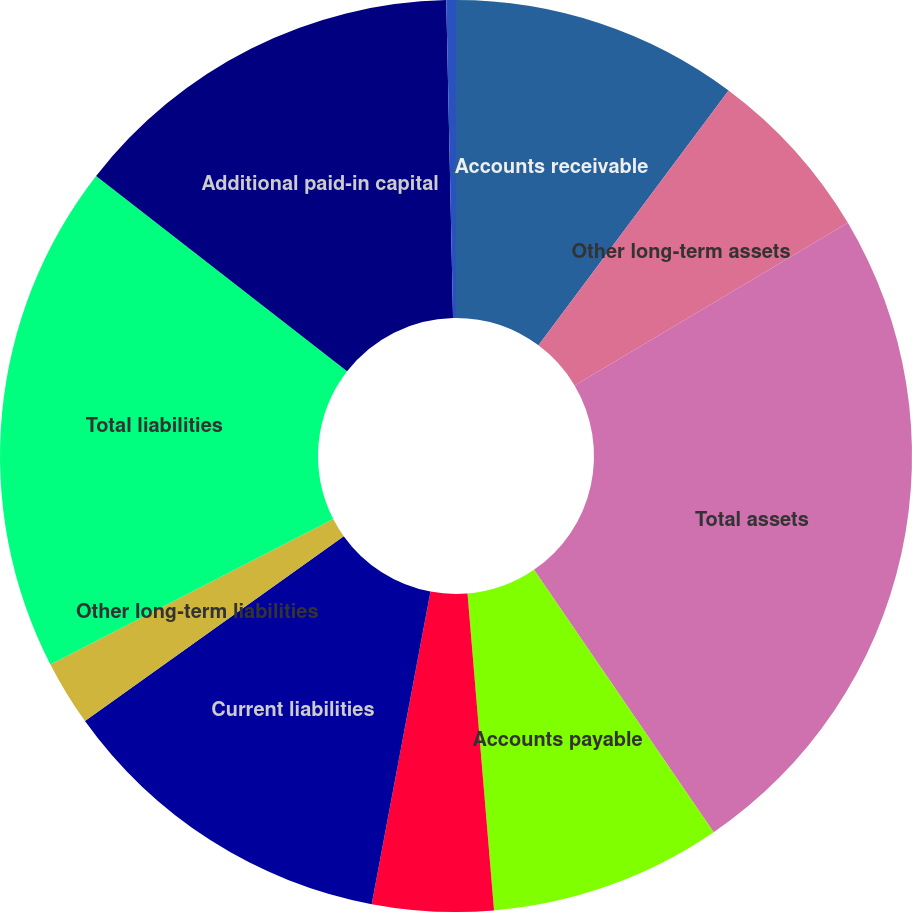<chart> <loc_0><loc_0><loc_500><loc_500><pie_chart><fcel>Accounts receivable<fcel>Other long-term assets<fcel>Total assets<fcel>Accounts payable<fcel>Other current liabilities<fcel>Current liabilities<fcel>Other long-term liabilities<fcel>Total liabilities<fcel>Additional paid-in capital<fcel>Accumulated other<nl><fcel>10.2%<fcel>6.26%<fcel>23.99%<fcel>8.23%<fcel>4.29%<fcel>12.17%<fcel>2.32%<fcel>18.08%<fcel>14.14%<fcel>0.34%<nl></chart> 